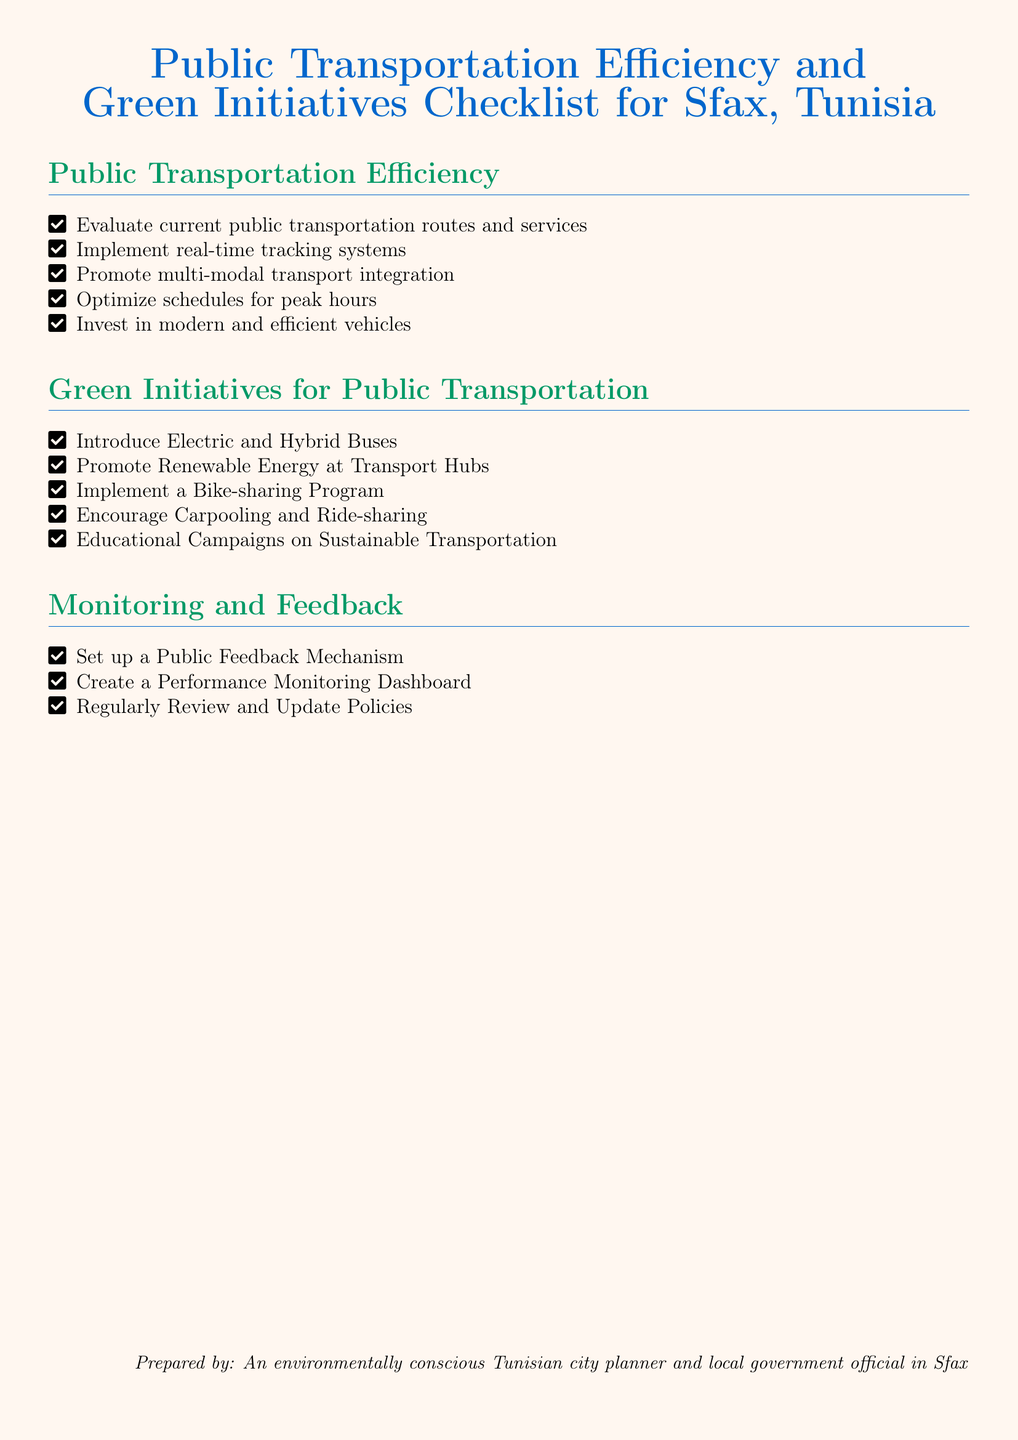What is the title of the document? The title is presented in the document's header, stating the focus on public transportation efficiency and green initiatives in Sfax, Tunisia.
Answer: Public Transportation Efficiency and Green Initiatives Checklist for Sfax, Tunisia How many items are listed under Public Transportation Efficiency? The document enumerates the specific efficiency measures in a list format, indicating the count of items presented.
Answer: Five What type of buses is suggested to be introduced? The document directly recommends certain types of buses to improve public transportation sustainability.
Answer: Electric and Hybrid Buses What is proposed to encourage sustainable transport usage? The checklist explicitly lists methods to promote sustainable transport, one of which is aimed at increasing shared transport options.
Answer: Educational Campaigns on Sustainable Transportation What system should be implemented for monitoring? The document outlines mechanisms for feedback and performance assessment for public transport services.
Answer: Performance Monitoring Dashboard How many sections are in the checklist? The document's structure includes distinct sections pertaining to different initiatives, allowing for a clear categorization of content.
Answer: Three 